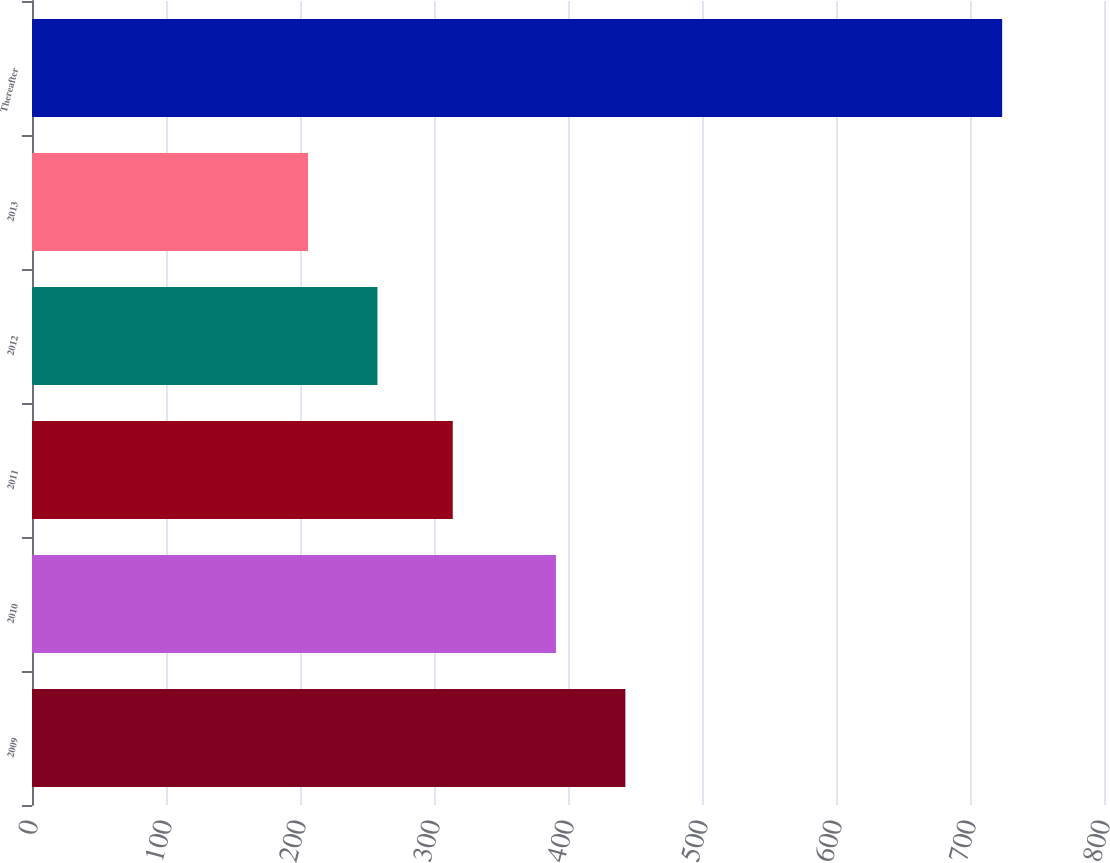Convert chart to OTSL. <chart><loc_0><loc_0><loc_500><loc_500><bar_chart><fcel>2009<fcel>2010<fcel>2011<fcel>2012<fcel>2013<fcel>Thereafter<nl><fcel>442.8<fcel>391<fcel>314<fcel>257.8<fcel>206<fcel>724<nl></chart> 